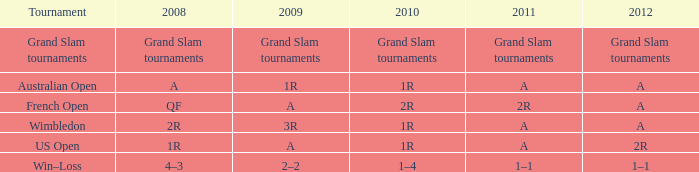Identify the 2010 and 2011 editions of "a" as well as the 2008 edition of "1r." 1R. 